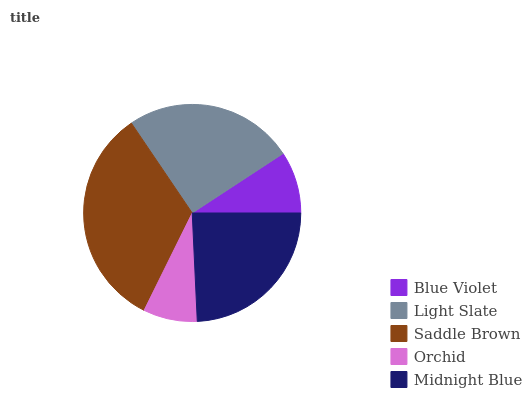Is Orchid the minimum?
Answer yes or no. Yes. Is Saddle Brown the maximum?
Answer yes or no. Yes. Is Light Slate the minimum?
Answer yes or no. No. Is Light Slate the maximum?
Answer yes or no. No. Is Light Slate greater than Blue Violet?
Answer yes or no. Yes. Is Blue Violet less than Light Slate?
Answer yes or no. Yes. Is Blue Violet greater than Light Slate?
Answer yes or no. No. Is Light Slate less than Blue Violet?
Answer yes or no. No. Is Midnight Blue the high median?
Answer yes or no. Yes. Is Midnight Blue the low median?
Answer yes or no. Yes. Is Blue Violet the high median?
Answer yes or no. No. Is Light Slate the low median?
Answer yes or no. No. 